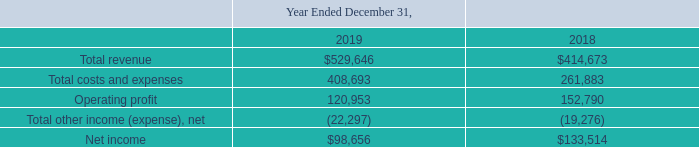GreenSky, Inc. NOTES TO CONSOLIDATED FINANCIAL STATEMENTS — (Continued) (United States Dollars in thousands, except per share data, unless otherwise stated)
The following table reflects the impact of consolidation of GS Holdings into the Consolidated Statements of Operations for the years indicated.
Which years does the table show? 2019, 2018. What was the total revenue in 2018?
Answer scale should be: thousand. 414,673. What was the operating profit in 2019?
Answer scale should be: thousand. 120,953. How many years did Total costs and expenses exceed $200,000 thousand? 2019##2018
Answer: 2. What was the change in operating profit between 2018 and 2019?
Answer scale should be: thousand. 120,953-152,790
Answer: -31837. What was the percentage change in the net income between 2018 and 2019?
Answer scale should be: percent. (98,656-133,514)/133,514
Answer: -26.11. 